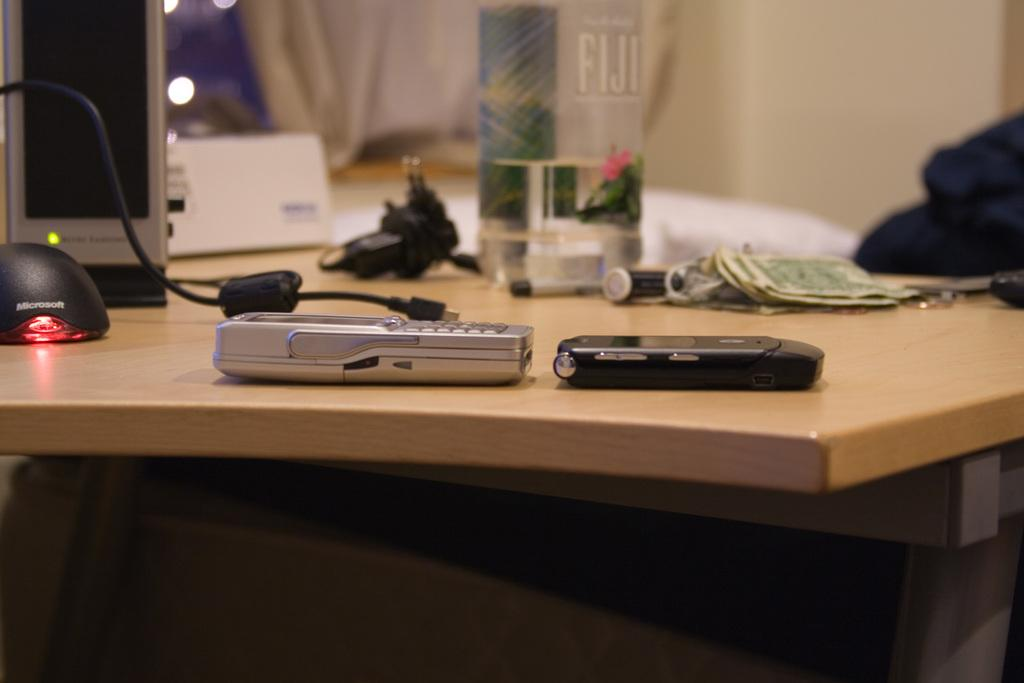What type of electronic devices can be seen in the image? There are mobile phones in the image. What can be found alongside the mobile phones? There is money, batteries, a bottle, cables, and a mouse (computer peripheral) in the image. What material is present in the image that might be used for cleaning or wiping? There is a cloth in the image. Where are the objects arranged in the image? The objects are arranged on a table. What can be seen in the background of the image? There is a wall in the background of the image. What type of trousers are the committee members wearing in the image? There is no committee or trousers present in the image. What color is the suit worn by the person in the image? There is no person wearing a suit in the image. 